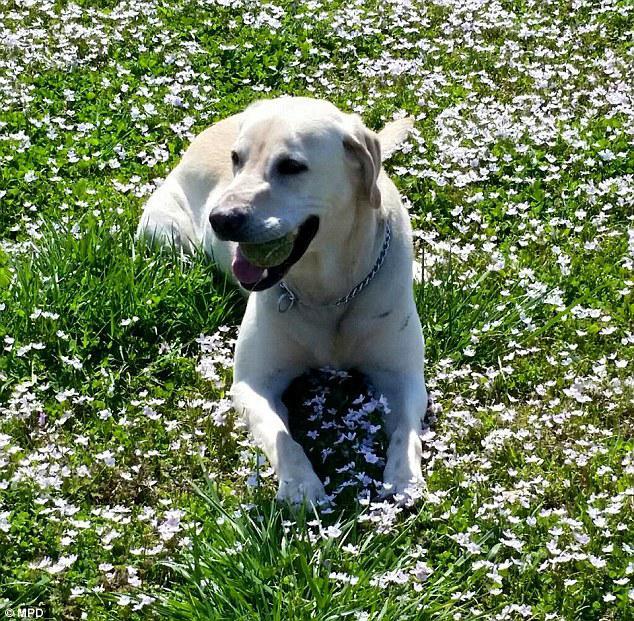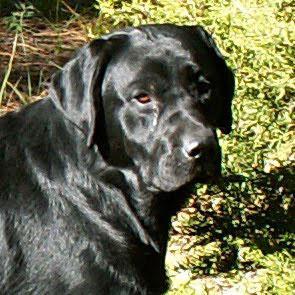The first image is the image on the left, the second image is the image on the right. Assess this claim about the two images: "There is at least one dog whose mouth is completely closed.". Correct or not? Answer yes or no. Yes. The first image is the image on the left, the second image is the image on the right. Analyze the images presented: Is the assertion "The dog in one of the images is wearing a red collar around its neck." valid? Answer yes or no. No. 